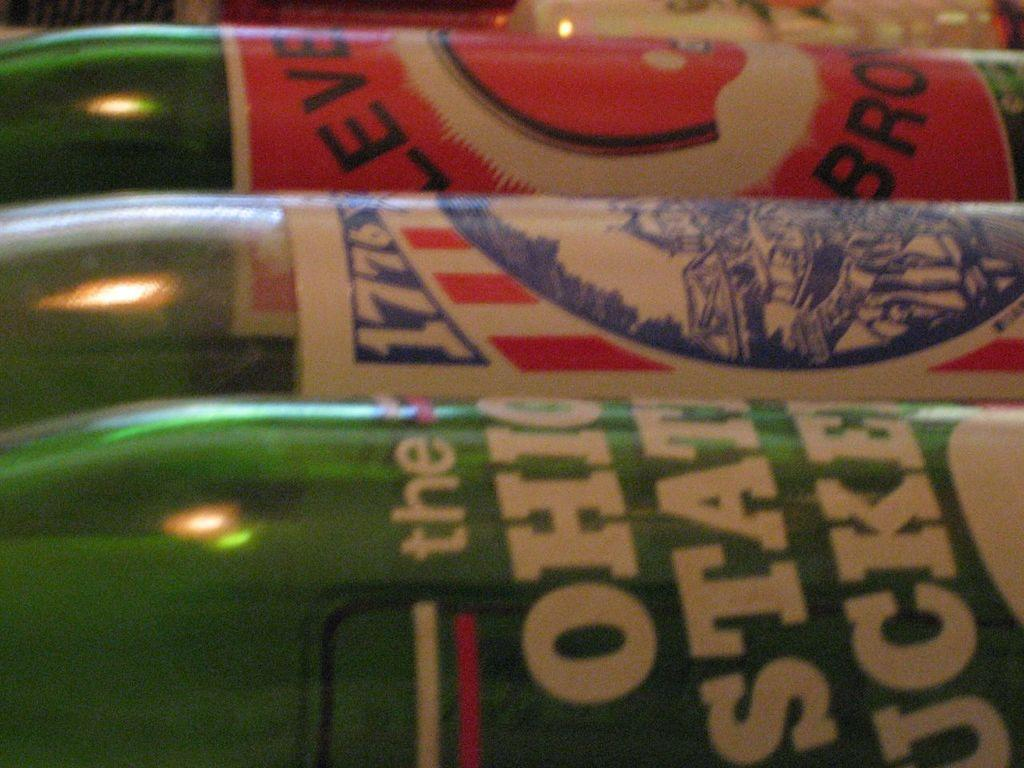<image>
Describe the image concisely. The name Ohio and the year 1776 are visible on some soda bottles. 